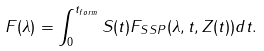Convert formula to latex. <formula><loc_0><loc_0><loc_500><loc_500>F ( { \lambda } ) = \int _ { 0 } ^ { t _ { f o r m } } S ( t ) F _ { S S P } ( { \lambda } , t , Z ( t ) ) d t .</formula> 